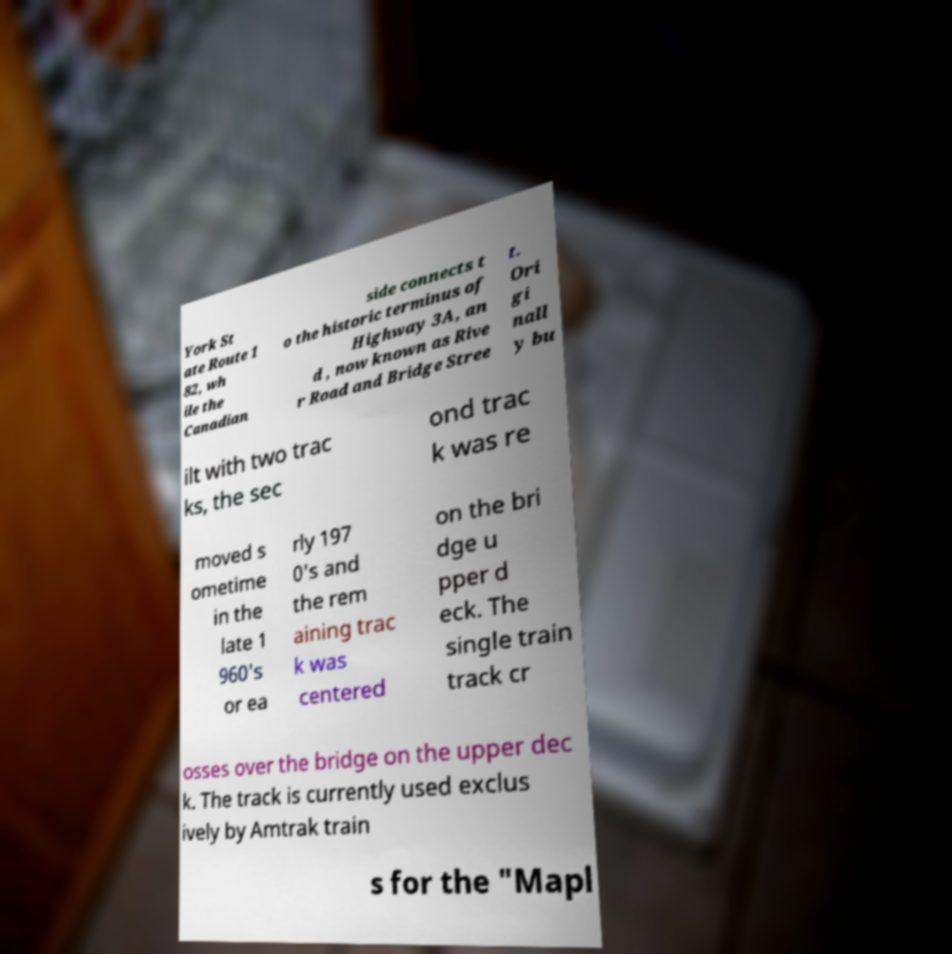Please identify and transcribe the text found in this image. York St ate Route 1 82, wh ile the Canadian side connects t o the historic terminus of Highway 3A, an d , now known as Rive r Road and Bridge Stree t. Ori gi nall y bu ilt with two trac ks, the sec ond trac k was re moved s ometime in the late 1 960's or ea rly 197 0's and the rem aining trac k was centered on the bri dge u pper d eck. The single train track cr osses over the bridge on the upper dec k. The track is currently used exclus ively by Amtrak train s for the "Mapl 